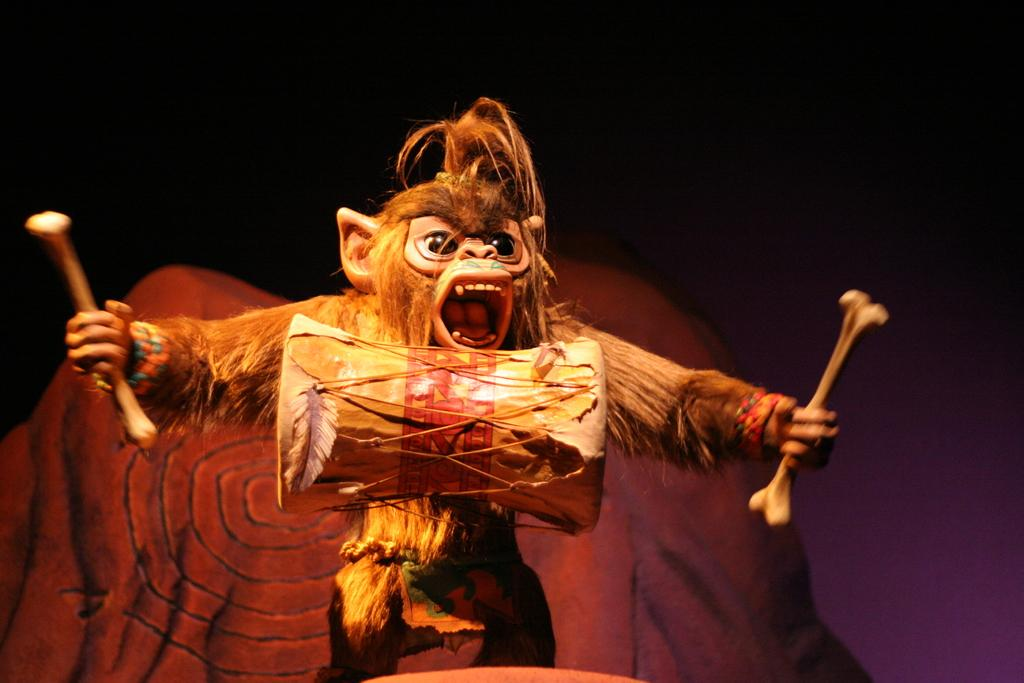What is the main subject of the image? The main subject of the image is a toy monkey. What is the toy monkey doing in the image? The toy monkey is playing drums. What color is the wall in the image? The wall in the image is brown. What color is the background of the image? The background of the image is black. What is the answer to the riddle hidden in the image? There is no riddle hidden in the image; it simply features a toy monkey playing drums against a brown wall with a black background. 